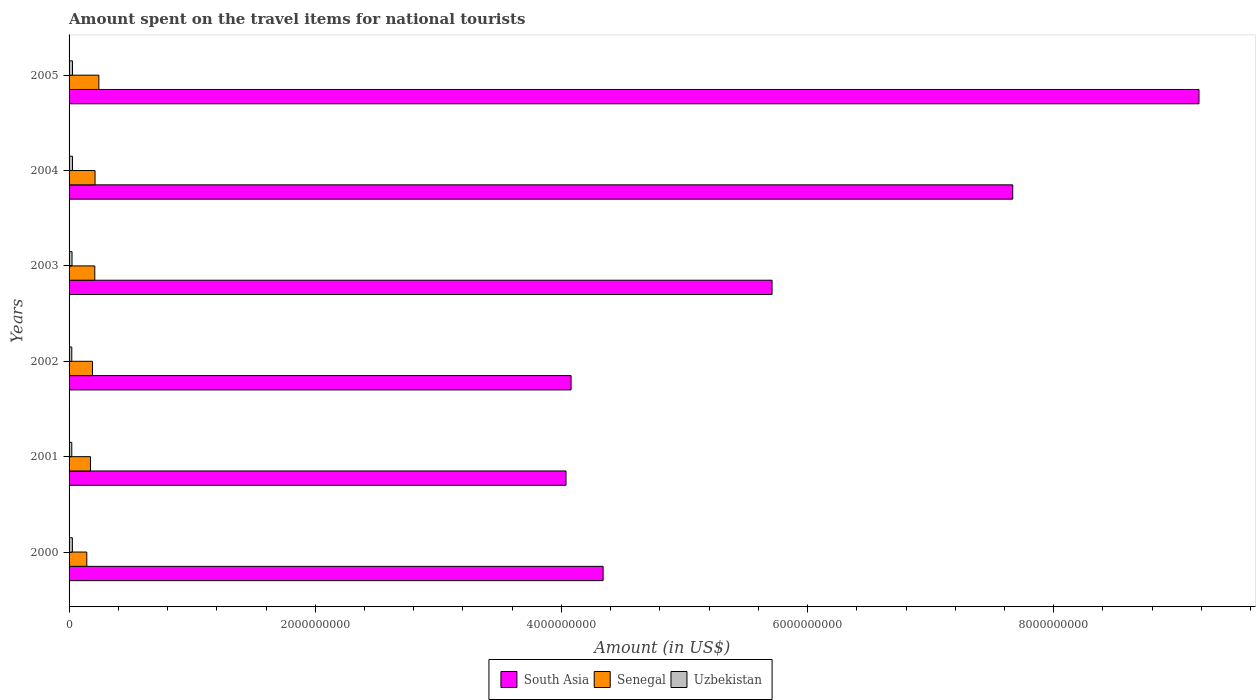How many groups of bars are there?
Make the answer very short. 6. Are the number of bars per tick equal to the number of legend labels?
Offer a very short reply. Yes. Are the number of bars on each tick of the Y-axis equal?
Keep it short and to the point. Yes. How many bars are there on the 1st tick from the top?
Give a very brief answer. 3. How many bars are there on the 3rd tick from the bottom?
Provide a short and direct response. 3. What is the label of the 5th group of bars from the top?
Give a very brief answer. 2001. What is the amount spent on the travel items for national tourists in Senegal in 2005?
Your response must be concise. 2.42e+08. Across all years, what is the maximum amount spent on the travel items for national tourists in Senegal?
Your answer should be very brief. 2.42e+08. Across all years, what is the minimum amount spent on the travel items for national tourists in South Asia?
Make the answer very short. 4.04e+09. In which year was the amount spent on the travel items for national tourists in Uzbekistan minimum?
Provide a short and direct response. 2001. What is the total amount spent on the travel items for national tourists in Senegal in the graph?
Offer a very short reply. 1.17e+09. What is the difference between the amount spent on the travel items for national tourists in Uzbekistan in 2002 and that in 2005?
Your answer should be compact. -6.00e+06. What is the difference between the amount spent on the travel items for national tourists in Uzbekistan in 2004 and the amount spent on the travel items for national tourists in South Asia in 2002?
Offer a terse response. -4.05e+09. What is the average amount spent on the travel items for national tourists in Uzbekistan per year?
Make the answer very short. 2.52e+07. In the year 2000, what is the difference between the amount spent on the travel items for national tourists in South Asia and amount spent on the travel items for national tourists in Uzbekistan?
Make the answer very short. 4.31e+09. What is the ratio of the amount spent on the travel items for national tourists in South Asia in 2000 to that in 2001?
Your answer should be very brief. 1.07. What is the difference between the highest and the second highest amount spent on the travel items for national tourists in Senegal?
Ensure brevity in your answer.  3.10e+07. What is the difference between the highest and the lowest amount spent on the travel items for national tourists in South Asia?
Your answer should be compact. 5.14e+09. In how many years, is the amount spent on the travel items for national tourists in South Asia greater than the average amount spent on the travel items for national tourists in South Asia taken over all years?
Give a very brief answer. 2. Is the sum of the amount spent on the travel items for national tourists in Senegal in 2000 and 2003 greater than the maximum amount spent on the travel items for national tourists in South Asia across all years?
Offer a very short reply. No. What does the 1st bar from the top in 2000 represents?
Provide a short and direct response. Uzbekistan. What does the 2nd bar from the bottom in 2003 represents?
Provide a succinct answer. Senegal. Is it the case that in every year, the sum of the amount spent on the travel items for national tourists in South Asia and amount spent on the travel items for national tourists in Senegal is greater than the amount spent on the travel items for national tourists in Uzbekistan?
Provide a short and direct response. Yes. How many bars are there?
Make the answer very short. 18. Does the graph contain any zero values?
Your response must be concise. No. How are the legend labels stacked?
Keep it short and to the point. Horizontal. What is the title of the graph?
Your answer should be compact. Amount spent on the travel items for national tourists. Does "Latin America(all income levels)" appear as one of the legend labels in the graph?
Keep it short and to the point. No. What is the label or title of the X-axis?
Keep it short and to the point. Amount (in US$). What is the label or title of the Y-axis?
Provide a short and direct response. Years. What is the Amount (in US$) of South Asia in 2000?
Keep it short and to the point. 4.34e+09. What is the Amount (in US$) in Senegal in 2000?
Give a very brief answer. 1.44e+08. What is the Amount (in US$) of Uzbekistan in 2000?
Provide a succinct answer. 2.70e+07. What is the Amount (in US$) of South Asia in 2001?
Offer a very short reply. 4.04e+09. What is the Amount (in US$) of Senegal in 2001?
Keep it short and to the point. 1.74e+08. What is the Amount (in US$) in Uzbekistan in 2001?
Offer a very short reply. 2.20e+07. What is the Amount (in US$) of South Asia in 2002?
Ensure brevity in your answer.  4.08e+09. What is the Amount (in US$) in Senegal in 2002?
Your answer should be compact. 1.90e+08. What is the Amount (in US$) in Uzbekistan in 2002?
Provide a short and direct response. 2.20e+07. What is the Amount (in US$) in South Asia in 2003?
Your response must be concise. 5.71e+09. What is the Amount (in US$) of Senegal in 2003?
Ensure brevity in your answer.  2.09e+08. What is the Amount (in US$) of Uzbekistan in 2003?
Your response must be concise. 2.40e+07. What is the Amount (in US$) of South Asia in 2004?
Provide a short and direct response. 7.67e+09. What is the Amount (in US$) of Senegal in 2004?
Your answer should be compact. 2.11e+08. What is the Amount (in US$) of Uzbekistan in 2004?
Provide a succinct answer. 2.80e+07. What is the Amount (in US$) of South Asia in 2005?
Your answer should be very brief. 9.18e+09. What is the Amount (in US$) of Senegal in 2005?
Keep it short and to the point. 2.42e+08. What is the Amount (in US$) in Uzbekistan in 2005?
Make the answer very short. 2.80e+07. Across all years, what is the maximum Amount (in US$) in South Asia?
Give a very brief answer. 9.18e+09. Across all years, what is the maximum Amount (in US$) in Senegal?
Ensure brevity in your answer.  2.42e+08. Across all years, what is the maximum Amount (in US$) of Uzbekistan?
Keep it short and to the point. 2.80e+07. Across all years, what is the minimum Amount (in US$) of South Asia?
Ensure brevity in your answer.  4.04e+09. Across all years, what is the minimum Amount (in US$) of Senegal?
Ensure brevity in your answer.  1.44e+08. Across all years, what is the minimum Amount (in US$) of Uzbekistan?
Give a very brief answer. 2.20e+07. What is the total Amount (in US$) of South Asia in the graph?
Offer a very short reply. 3.50e+1. What is the total Amount (in US$) of Senegal in the graph?
Your answer should be compact. 1.17e+09. What is the total Amount (in US$) of Uzbekistan in the graph?
Make the answer very short. 1.51e+08. What is the difference between the Amount (in US$) in South Asia in 2000 and that in 2001?
Your response must be concise. 3.01e+08. What is the difference between the Amount (in US$) in Senegal in 2000 and that in 2001?
Make the answer very short. -3.00e+07. What is the difference between the Amount (in US$) of Uzbekistan in 2000 and that in 2001?
Your response must be concise. 5.00e+06. What is the difference between the Amount (in US$) in South Asia in 2000 and that in 2002?
Make the answer very short. 2.60e+08. What is the difference between the Amount (in US$) of Senegal in 2000 and that in 2002?
Give a very brief answer. -4.60e+07. What is the difference between the Amount (in US$) in Uzbekistan in 2000 and that in 2002?
Ensure brevity in your answer.  5.00e+06. What is the difference between the Amount (in US$) in South Asia in 2000 and that in 2003?
Your answer should be compact. -1.37e+09. What is the difference between the Amount (in US$) of Senegal in 2000 and that in 2003?
Your response must be concise. -6.50e+07. What is the difference between the Amount (in US$) of Uzbekistan in 2000 and that in 2003?
Keep it short and to the point. 3.00e+06. What is the difference between the Amount (in US$) of South Asia in 2000 and that in 2004?
Provide a succinct answer. -3.33e+09. What is the difference between the Amount (in US$) of Senegal in 2000 and that in 2004?
Provide a succinct answer. -6.70e+07. What is the difference between the Amount (in US$) in South Asia in 2000 and that in 2005?
Your response must be concise. -4.84e+09. What is the difference between the Amount (in US$) in Senegal in 2000 and that in 2005?
Provide a short and direct response. -9.80e+07. What is the difference between the Amount (in US$) in South Asia in 2001 and that in 2002?
Your response must be concise. -4.12e+07. What is the difference between the Amount (in US$) of Senegal in 2001 and that in 2002?
Give a very brief answer. -1.60e+07. What is the difference between the Amount (in US$) in South Asia in 2001 and that in 2003?
Your answer should be very brief. -1.67e+09. What is the difference between the Amount (in US$) in Senegal in 2001 and that in 2003?
Offer a very short reply. -3.50e+07. What is the difference between the Amount (in US$) in Uzbekistan in 2001 and that in 2003?
Provide a succinct answer. -2.00e+06. What is the difference between the Amount (in US$) of South Asia in 2001 and that in 2004?
Provide a short and direct response. -3.63e+09. What is the difference between the Amount (in US$) in Senegal in 2001 and that in 2004?
Offer a terse response. -3.70e+07. What is the difference between the Amount (in US$) of Uzbekistan in 2001 and that in 2004?
Make the answer very short. -6.00e+06. What is the difference between the Amount (in US$) of South Asia in 2001 and that in 2005?
Offer a terse response. -5.14e+09. What is the difference between the Amount (in US$) of Senegal in 2001 and that in 2005?
Give a very brief answer. -6.80e+07. What is the difference between the Amount (in US$) in Uzbekistan in 2001 and that in 2005?
Keep it short and to the point. -6.00e+06. What is the difference between the Amount (in US$) in South Asia in 2002 and that in 2003?
Ensure brevity in your answer.  -1.63e+09. What is the difference between the Amount (in US$) of Senegal in 2002 and that in 2003?
Provide a short and direct response. -1.90e+07. What is the difference between the Amount (in US$) of South Asia in 2002 and that in 2004?
Make the answer very short. -3.59e+09. What is the difference between the Amount (in US$) in Senegal in 2002 and that in 2004?
Provide a short and direct response. -2.10e+07. What is the difference between the Amount (in US$) of Uzbekistan in 2002 and that in 2004?
Your answer should be compact. -6.00e+06. What is the difference between the Amount (in US$) in South Asia in 2002 and that in 2005?
Provide a short and direct response. -5.10e+09. What is the difference between the Amount (in US$) of Senegal in 2002 and that in 2005?
Provide a succinct answer. -5.20e+07. What is the difference between the Amount (in US$) of Uzbekistan in 2002 and that in 2005?
Give a very brief answer. -6.00e+06. What is the difference between the Amount (in US$) of South Asia in 2003 and that in 2004?
Provide a succinct answer. -1.96e+09. What is the difference between the Amount (in US$) in South Asia in 2003 and that in 2005?
Give a very brief answer. -3.47e+09. What is the difference between the Amount (in US$) of Senegal in 2003 and that in 2005?
Ensure brevity in your answer.  -3.30e+07. What is the difference between the Amount (in US$) in Uzbekistan in 2003 and that in 2005?
Your answer should be compact. -4.00e+06. What is the difference between the Amount (in US$) of South Asia in 2004 and that in 2005?
Provide a succinct answer. -1.51e+09. What is the difference between the Amount (in US$) in Senegal in 2004 and that in 2005?
Make the answer very short. -3.10e+07. What is the difference between the Amount (in US$) in South Asia in 2000 and the Amount (in US$) in Senegal in 2001?
Make the answer very short. 4.16e+09. What is the difference between the Amount (in US$) in South Asia in 2000 and the Amount (in US$) in Uzbekistan in 2001?
Make the answer very short. 4.32e+09. What is the difference between the Amount (in US$) of Senegal in 2000 and the Amount (in US$) of Uzbekistan in 2001?
Give a very brief answer. 1.22e+08. What is the difference between the Amount (in US$) in South Asia in 2000 and the Amount (in US$) in Senegal in 2002?
Give a very brief answer. 4.15e+09. What is the difference between the Amount (in US$) in South Asia in 2000 and the Amount (in US$) in Uzbekistan in 2002?
Ensure brevity in your answer.  4.32e+09. What is the difference between the Amount (in US$) of Senegal in 2000 and the Amount (in US$) of Uzbekistan in 2002?
Your response must be concise. 1.22e+08. What is the difference between the Amount (in US$) of South Asia in 2000 and the Amount (in US$) of Senegal in 2003?
Make the answer very short. 4.13e+09. What is the difference between the Amount (in US$) of South Asia in 2000 and the Amount (in US$) of Uzbekistan in 2003?
Your response must be concise. 4.31e+09. What is the difference between the Amount (in US$) of Senegal in 2000 and the Amount (in US$) of Uzbekistan in 2003?
Your response must be concise. 1.20e+08. What is the difference between the Amount (in US$) of South Asia in 2000 and the Amount (in US$) of Senegal in 2004?
Offer a terse response. 4.13e+09. What is the difference between the Amount (in US$) of South Asia in 2000 and the Amount (in US$) of Uzbekistan in 2004?
Offer a very short reply. 4.31e+09. What is the difference between the Amount (in US$) in Senegal in 2000 and the Amount (in US$) in Uzbekistan in 2004?
Keep it short and to the point. 1.16e+08. What is the difference between the Amount (in US$) of South Asia in 2000 and the Amount (in US$) of Senegal in 2005?
Your answer should be compact. 4.10e+09. What is the difference between the Amount (in US$) in South Asia in 2000 and the Amount (in US$) in Uzbekistan in 2005?
Offer a very short reply. 4.31e+09. What is the difference between the Amount (in US$) of Senegal in 2000 and the Amount (in US$) of Uzbekistan in 2005?
Offer a very short reply. 1.16e+08. What is the difference between the Amount (in US$) in South Asia in 2001 and the Amount (in US$) in Senegal in 2002?
Ensure brevity in your answer.  3.85e+09. What is the difference between the Amount (in US$) in South Asia in 2001 and the Amount (in US$) in Uzbekistan in 2002?
Your response must be concise. 4.02e+09. What is the difference between the Amount (in US$) of Senegal in 2001 and the Amount (in US$) of Uzbekistan in 2002?
Provide a short and direct response. 1.52e+08. What is the difference between the Amount (in US$) of South Asia in 2001 and the Amount (in US$) of Senegal in 2003?
Provide a short and direct response. 3.83e+09. What is the difference between the Amount (in US$) of South Asia in 2001 and the Amount (in US$) of Uzbekistan in 2003?
Ensure brevity in your answer.  4.01e+09. What is the difference between the Amount (in US$) of Senegal in 2001 and the Amount (in US$) of Uzbekistan in 2003?
Your answer should be compact. 1.50e+08. What is the difference between the Amount (in US$) of South Asia in 2001 and the Amount (in US$) of Senegal in 2004?
Provide a short and direct response. 3.83e+09. What is the difference between the Amount (in US$) in South Asia in 2001 and the Amount (in US$) in Uzbekistan in 2004?
Offer a terse response. 4.01e+09. What is the difference between the Amount (in US$) of Senegal in 2001 and the Amount (in US$) of Uzbekistan in 2004?
Give a very brief answer. 1.46e+08. What is the difference between the Amount (in US$) in South Asia in 2001 and the Amount (in US$) in Senegal in 2005?
Keep it short and to the point. 3.80e+09. What is the difference between the Amount (in US$) of South Asia in 2001 and the Amount (in US$) of Uzbekistan in 2005?
Your response must be concise. 4.01e+09. What is the difference between the Amount (in US$) in Senegal in 2001 and the Amount (in US$) in Uzbekistan in 2005?
Keep it short and to the point. 1.46e+08. What is the difference between the Amount (in US$) of South Asia in 2002 and the Amount (in US$) of Senegal in 2003?
Make the answer very short. 3.87e+09. What is the difference between the Amount (in US$) of South Asia in 2002 and the Amount (in US$) of Uzbekistan in 2003?
Your answer should be very brief. 4.05e+09. What is the difference between the Amount (in US$) in Senegal in 2002 and the Amount (in US$) in Uzbekistan in 2003?
Your answer should be very brief. 1.66e+08. What is the difference between the Amount (in US$) of South Asia in 2002 and the Amount (in US$) of Senegal in 2004?
Offer a terse response. 3.87e+09. What is the difference between the Amount (in US$) in South Asia in 2002 and the Amount (in US$) in Uzbekistan in 2004?
Provide a short and direct response. 4.05e+09. What is the difference between the Amount (in US$) in Senegal in 2002 and the Amount (in US$) in Uzbekistan in 2004?
Offer a terse response. 1.62e+08. What is the difference between the Amount (in US$) of South Asia in 2002 and the Amount (in US$) of Senegal in 2005?
Give a very brief answer. 3.84e+09. What is the difference between the Amount (in US$) of South Asia in 2002 and the Amount (in US$) of Uzbekistan in 2005?
Keep it short and to the point. 4.05e+09. What is the difference between the Amount (in US$) in Senegal in 2002 and the Amount (in US$) in Uzbekistan in 2005?
Your response must be concise. 1.62e+08. What is the difference between the Amount (in US$) of South Asia in 2003 and the Amount (in US$) of Senegal in 2004?
Offer a terse response. 5.50e+09. What is the difference between the Amount (in US$) of South Asia in 2003 and the Amount (in US$) of Uzbekistan in 2004?
Your answer should be compact. 5.68e+09. What is the difference between the Amount (in US$) of Senegal in 2003 and the Amount (in US$) of Uzbekistan in 2004?
Offer a terse response. 1.81e+08. What is the difference between the Amount (in US$) of South Asia in 2003 and the Amount (in US$) of Senegal in 2005?
Your answer should be very brief. 5.47e+09. What is the difference between the Amount (in US$) of South Asia in 2003 and the Amount (in US$) of Uzbekistan in 2005?
Keep it short and to the point. 5.68e+09. What is the difference between the Amount (in US$) in Senegal in 2003 and the Amount (in US$) in Uzbekistan in 2005?
Offer a very short reply. 1.81e+08. What is the difference between the Amount (in US$) in South Asia in 2004 and the Amount (in US$) in Senegal in 2005?
Ensure brevity in your answer.  7.43e+09. What is the difference between the Amount (in US$) in South Asia in 2004 and the Amount (in US$) in Uzbekistan in 2005?
Your answer should be very brief. 7.64e+09. What is the difference between the Amount (in US$) of Senegal in 2004 and the Amount (in US$) of Uzbekistan in 2005?
Offer a terse response. 1.83e+08. What is the average Amount (in US$) in South Asia per year?
Give a very brief answer. 5.84e+09. What is the average Amount (in US$) of Senegal per year?
Provide a succinct answer. 1.95e+08. What is the average Amount (in US$) of Uzbekistan per year?
Ensure brevity in your answer.  2.52e+07. In the year 2000, what is the difference between the Amount (in US$) in South Asia and Amount (in US$) in Senegal?
Provide a succinct answer. 4.19e+09. In the year 2000, what is the difference between the Amount (in US$) in South Asia and Amount (in US$) in Uzbekistan?
Keep it short and to the point. 4.31e+09. In the year 2000, what is the difference between the Amount (in US$) of Senegal and Amount (in US$) of Uzbekistan?
Keep it short and to the point. 1.17e+08. In the year 2001, what is the difference between the Amount (in US$) in South Asia and Amount (in US$) in Senegal?
Keep it short and to the point. 3.86e+09. In the year 2001, what is the difference between the Amount (in US$) in South Asia and Amount (in US$) in Uzbekistan?
Your answer should be compact. 4.02e+09. In the year 2001, what is the difference between the Amount (in US$) in Senegal and Amount (in US$) in Uzbekistan?
Your response must be concise. 1.52e+08. In the year 2002, what is the difference between the Amount (in US$) of South Asia and Amount (in US$) of Senegal?
Keep it short and to the point. 3.89e+09. In the year 2002, what is the difference between the Amount (in US$) in South Asia and Amount (in US$) in Uzbekistan?
Offer a terse response. 4.06e+09. In the year 2002, what is the difference between the Amount (in US$) of Senegal and Amount (in US$) of Uzbekistan?
Your answer should be very brief. 1.68e+08. In the year 2003, what is the difference between the Amount (in US$) of South Asia and Amount (in US$) of Senegal?
Keep it short and to the point. 5.50e+09. In the year 2003, what is the difference between the Amount (in US$) of South Asia and Amount (in US$) of Uzbekistan?
Provide a succinct answer. 5.69e+09. In the year 2003, what is the difference between the Amount (in US$) in Senegal and Amount (in US$) in Uzbekistan?
Give a very brief answer. 1.85e+08. In the year 2004, what is the difference between the Amount (in US$) of South Asia and Amount (in US$) of Senegal?
Your answer should be compact. 7.46e+09. In the year 2004, what is the difference between the Amount (in US$) of South Asia and Amount (in US$) of Uzbekistan?
Your answer should be compact. 7.64e+09. In the year 2004, what is the difference between the Amount (in US$) in Senegal and Amount (in US$) in Uzbekistan?
Your response must be concise. 1.83e+08. In the year 2005, what is the difference between the Amount (in US$) of South Asia and Amount (in US$) of Senegal?
Provide a succinct answer. 8.94e+09. In the year 2005, what is the difference between the Amount (in US$) of South Asia and Amount (in US$) of Uzbekistan?
Keep it short and to the point. 9.15e+09. In the year 2005, what is the difference between the Amount (in US$) in Senegal and Amount (in US$) in Uzbekistan?
Ensure brevity in your answer.  2.14e+08. What is the ratio of the Amount (in US$) in South Asia in 2000 to that in 2001?
Give a very brief answer. 1.07. What is the ratio of the Amount (in US$) of Senegal in 2000 to that in 2001?
Make the answer very short. 0.83. What is the ratio of the Amount (in US$) of Uzbekistan in 2000 to that in 2001?
Provide a short and direct response. 1.23. What is the ratio of the Amount (in US$) in South Asia in 2000 to that in 2002?
Offer a terse response. 1.06. What is the ratio of the Amount (in US$) of Senegal in 2000 to that in 2002?
Provide a succinct answer. 0.76. What is the ratio of the Amount (in US$) of Uzbekistan in 2000 to that in 2002?
Ensure brevity in your answer.  1.23. What is the ratio of the Amount (in US$) of South Asia in 2000 to that in 2003?
Offer a very short reply. 0.76. What is the ratio of the Amount (in US$) in Senegal in 2000 to that in 2003?
Your response must be concise. 0.69. What is the ratio of the Amount (in US$) of Uzbekistan in 2000 to that in 2003?
Offer a terse response. 1.12. What is the ratio of the Amount (in US$) in South Asia in 2000 to that in 2004?
Provide a succinct answer. 0.57. What is the ratio of the Amount (in US$) in Senegal in 2000 to that in 2004?
Keep it short and to the point. 0.68. What is the ratio of the Amount (in US$) in Uzbekistan in 2000 to that in 2004?
Give a very brief answer. 0.96. What is the ratio of the Amount (in US$) of South Asia in 2000 to that in 2005?
Ensure brevity in your answer.  0.47. What is the ratio of the Amount (in US$) of Senegal in 2000 to that in 2005?
Offer a very short reply. 0.59. What is the ratio of the Amount (in US$) in South Asia in 2001 to that in 2002?
Give a very brief answer. 0.99. What is the ratio of the Amount (in US$) in Senegal in 2001 to that in 2002?
Give a very brief answer. 0.92. What is the ratio of the Amount (in US$) of South Asia in 2001 to that in 2003?
Provide a succinct answer. 0.71. What is the ratio of the Amount (in US$) of Senegal in 2001 to that in 2003?
Your answer should be very brief. 0.83. What is the ratio of the Amount (in US$) of South Asia in 2001 to that in 2004?
Your answer should be compact. 0.53. What is the ratio of the Amount (in US$) of Senegal in 2001 to that in 2004?
Provide a succinct answer. 0.82. What is the ratio of the Amount (in US$) of Uzbekistan in 2001 to that in 2004?
Ensure brevity in your answer.  0.79. What is the ratio of the Amount (in US$) in South Asia in 2001 to that in 2005?
Keep it short and to the point. 0.44. What is the ratio of the Amount (in US$) of Senegal in 2001 to that in 2005?
Your response must be concise. 0.72. What is the ratio of the Amount (in US$) of Uzbekistan in 2001 to that in 2005?
Give a very brief answer. 0.79. What is the ratio of the Amount (in US$) in South Asia in 2002 to that in 2003?
Offer a very short reply. 0.71. What is the ratio of the Amount (in US$) of Uzbekistan in 2002 to that in 2003?
Provide a short and direct response. 0.92. What is the ratio of the Amount (in US$) of South Asia in 2002 to that in 2004?
Offer a terse response. 0.53. What is the ratio of the Amount (in US$) in Senegal in 2002 to that in 2004?
Provide a succinct answer. 0.9. What is the ratio of the Amount (in US$) of Uzbekistan in 2002 to that in 2004?
Ensure brevity in your answer.  0.79. What is the ratio of the Amount (in US$) of South Asia in 2002 to that in 2005?
Offer a terse response. 0.44. What is the ratio of the Amount (in US$) in Senegal in 2002 to that in 2005?
Your answer should be compact. 0.79. What is the ratio of the Amount (in US$) of Uzbekistan in 2002 to that in 2005?
Ensure brevity in your answer.  0.79. What is the ratio of the Amount (in US$) of South Asia in 2003 to that in 2004?
Provide a succinct answer. 0.74. What is the ratio of the Amount (in US$) in South Asia in 2003 to that in 2005?
Make the answer very short. 0.62. What is the ratio of the Amount (in US$) of Senegal in 2003 to that in 2005?
Provide a succinct answer. 0.86. What is the ratio of the Amount (in US$) in South Asia in 2004 to that in 2005?
Your answer should be very brief. 0.84. What is the ratio of the Amount (in US$) of Senegal in 2004 to that in 2005?
Your response must be concise. 0.87. What is the difference between the highest and the second highest Amount (in US$) in South Asia?
Your response must be concise. 1.51e+09. What is the difference between the highest and the second highest Amount (in US$) in Senegal?
Ensure brevity in your answer.  3.10e+07. What is the difference between the highest and the lowest Amount (in US$) of South Asia?
Offer a very short reply. 5.14e+09. What is the difference between the highest and the lowest Amount (in US$) of Senegal?
Give a very brief answer. 9.80e+07. 